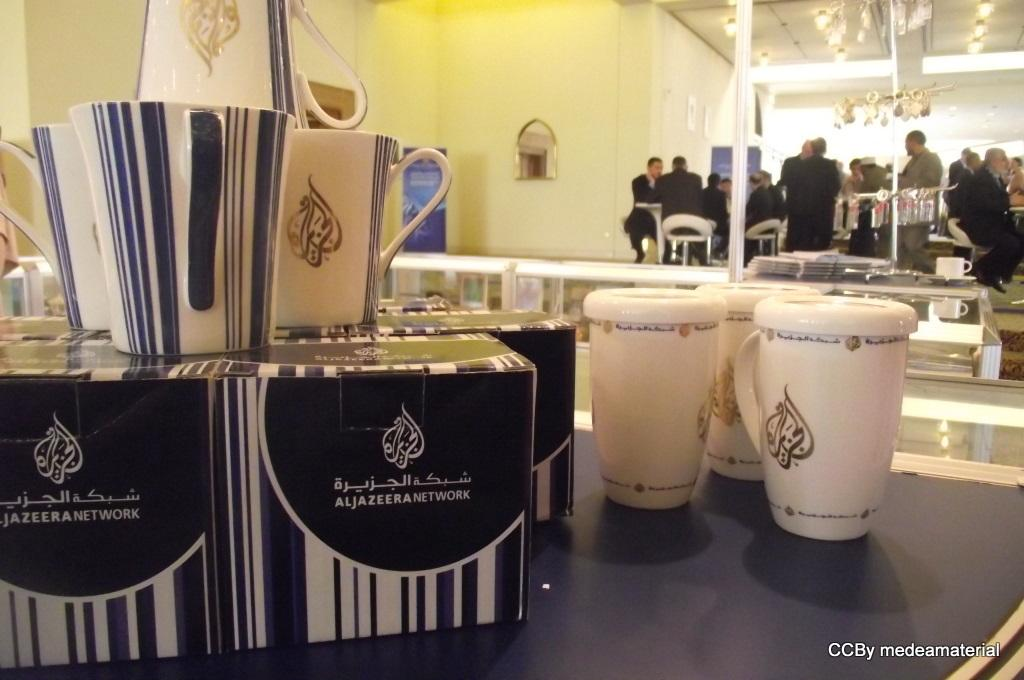<image>
Render a clear and concise summary of the photo. Two boxes that said Aljazeera Network with cups on it. 